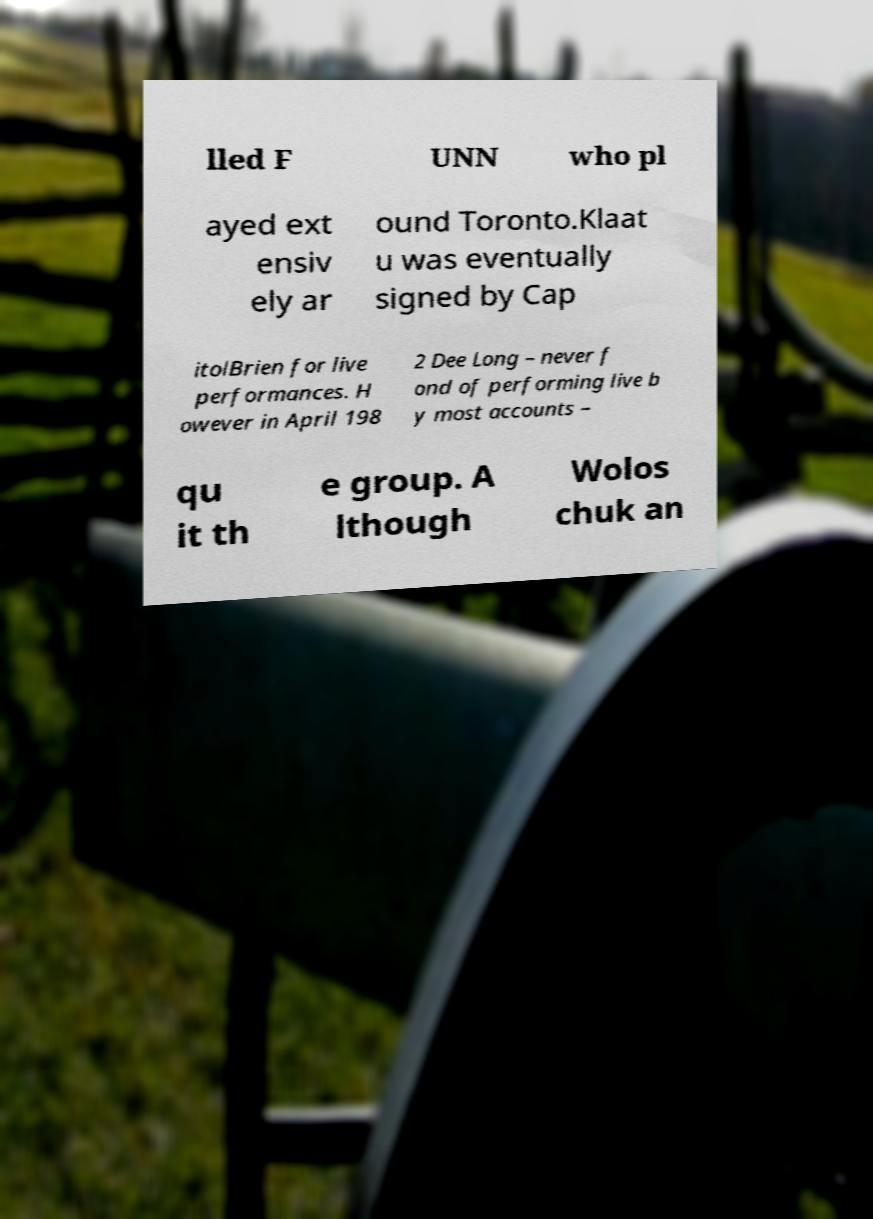Can you read and provide the text displayed in the image?This photo seems to have some interesting text. Can you extract and type it out for me? lled F UNN who pl ayed ext ensiv ely ar ound Toronto.Klaat u was eventually signed by Cap itolBrien for live performances. H owever in April 198 2 Dee Long – never f ond of performing live b y most accounts – qu it th e group. A lthough Wolos chuk an 